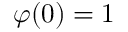Convert formula to latex. <formula><loc_0><loc_0><loc_500><loc_500>\varphi ( 0 ) = 1</formula> 